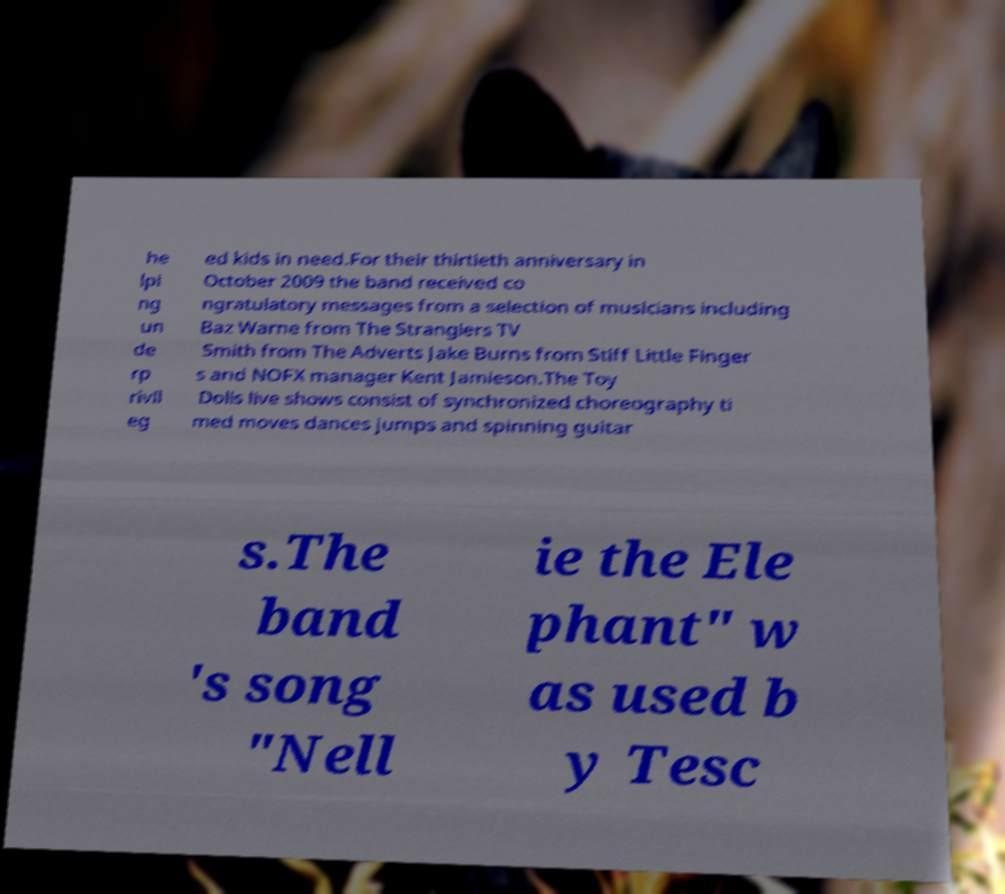There's text embedded in this image that I need extracted. Can you transcribe it verbatim? he lpi ng un de rp rivil eg ed kids in need.For their thirtieth anniversary in October 2009 the band received co ngratulatory messages from a selection of musicians including Baz Warne from The Stranglers TV Smith from The Adverts Jake Burns from Stiff Little Finger s and NOFX manager Kent Jamieson.The Toy Dolls live shows consist of synchronized choreography ti med moves dances jumps and spinning guitar s.The band 's song "Nell ie the Ele phant" w as used b y Tesc 